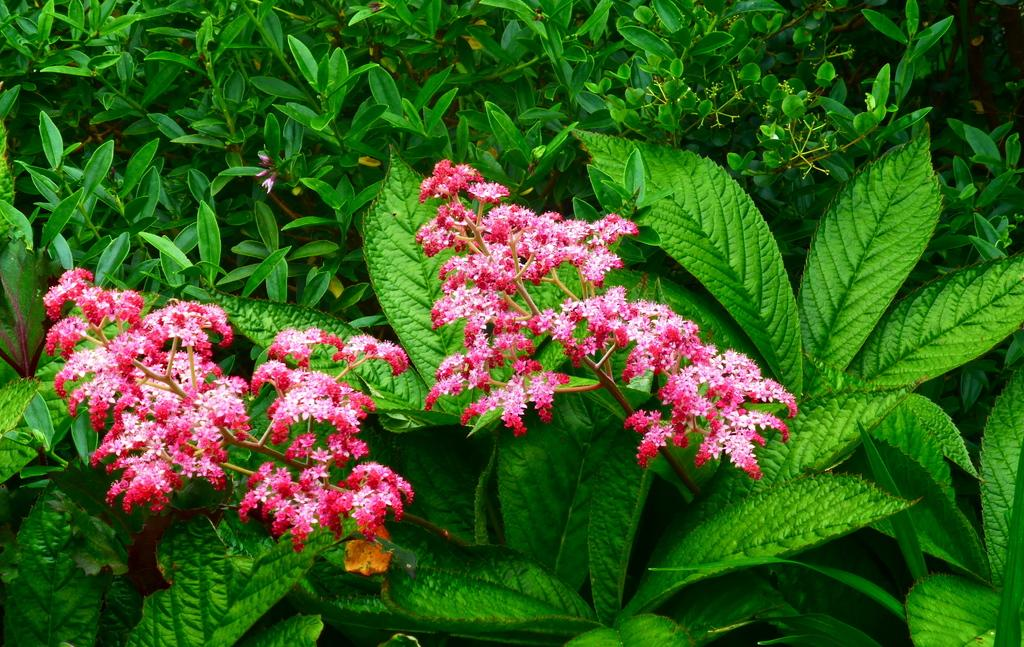What type of flora can be seen in the image? There are flowers in the image. What is the color of the flowers? The flowers are pink in color. What can be seen in the background of the image? There are plants in the background of the image. What is the color of the plants? The plants are green in color. Can you tell me how many guitars are leaning against the dock in the image? There is no dock or guitar present in the image; it features flowers and plants. 